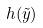Convert formula to latex. <formula><loc_0><loc_0><loc_500><loc_500>h ( \tilde { y } )</formula> 